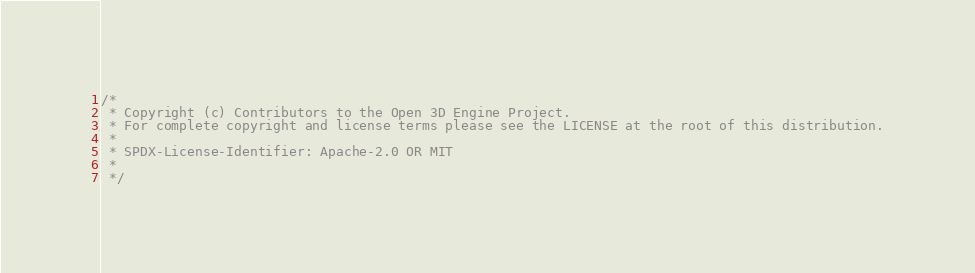<code> <loc_0><loc_0><loc_500><loc_500><_C++_>/*
 * Copyright (c) Contributors to the Open 3D Engine Project.
 * For complete copyright and license terms please see the LICENSE at the root of this distribution.
 *
 * SPDX-License-Identifier: Apache-2.0 OR MIT
 *
 */</code> 